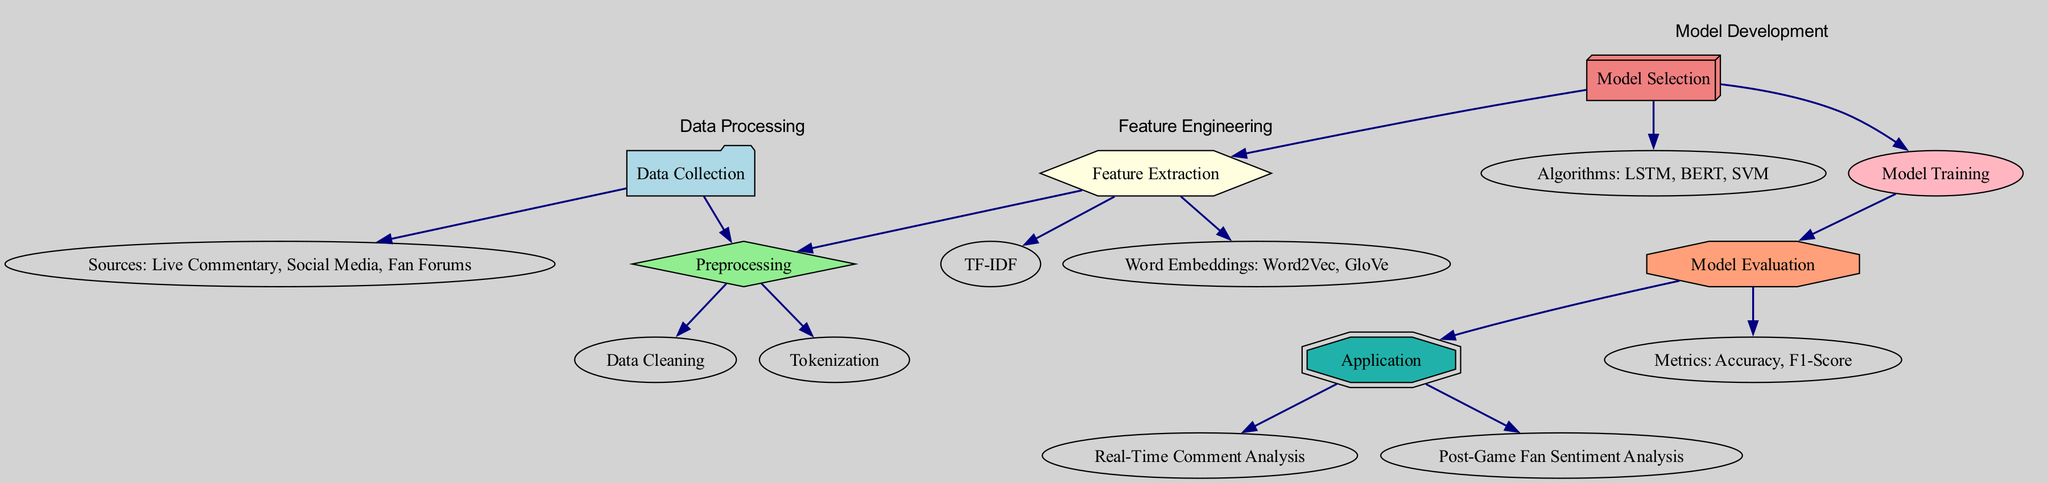What are the sources of data collection? The diagram includes a node labeled "Sources: Live Commentary, Social Media, Fan Forums," indicating that these are the three main sources for data collection.
Answer: Live Commentary, Social Media, Fan Forums How many nodes are present in the diagram? By counting the nodes listed in the diagram (Data Collection, Sources, Preprocessing, Cleaning, Tokenization, Feature Extraction, TF-IDF, Word Embeddings, Model Selection, Algorithms, Training, Evaluation, Metrics, Application, Real-Time Analysis, Post-Game Fan Sentiment Analysis), we find a total of 15 nodes.
Answer: 15 What follows after data preprocessing? The diagram shows that after the "Preprocessing" node, both "Data Cleaning" and "Tokenization" nodes are next, indicating they are the subsequent steps.
Answer: Data Cleaning, Tokenization Which model evaluation metrics are mentioned? The metrics node in the diagram is labeled "Metrics: Accuracy, F1-Score," indicating these are the evaluation metrics being considered.
Answer: Accuracy, F1-Score What type of algorithms are involved in model selection? Under the "Algorithms" node, the types listed in the diagram are "LSTM, BERT, SVM," suggesting these are the algorithms chosen for model selection.
Answer: LSTM, BERT, SVM What is the purpose of the "Application" node? The "Application" node connects to "Real-Time Comment Analysis" and "Post-Game Fan Sentiment Analysis," which implies that the purpose of the Application node is to implement the results of the sentiment analysis in these two contexts.
Answer: Implement sentiment analysis results How does preprocessing relate to feature extraction? The diagram shows an edge going from the "Preprocessing" node to the "Feature Extraction" node, indicating that preprocessing is a prerequisite step before feature extraction can occur.
Answer: Preprocessing is a prerequisite for feature extraction Which step comes directly before model training? According to the diagram flow, "Model Selection" comes directly before "Training," indicating that model selection is completed prior to commencing model training.
Answer: Model Selection What type of analysis can be performed in real-time? The diagram specifies that the "Application" node connects to "Real-Time Comment Analysis," indicating that this is the real-time analysis that can be performed.
Answer: Real-Time Comment Analysis 